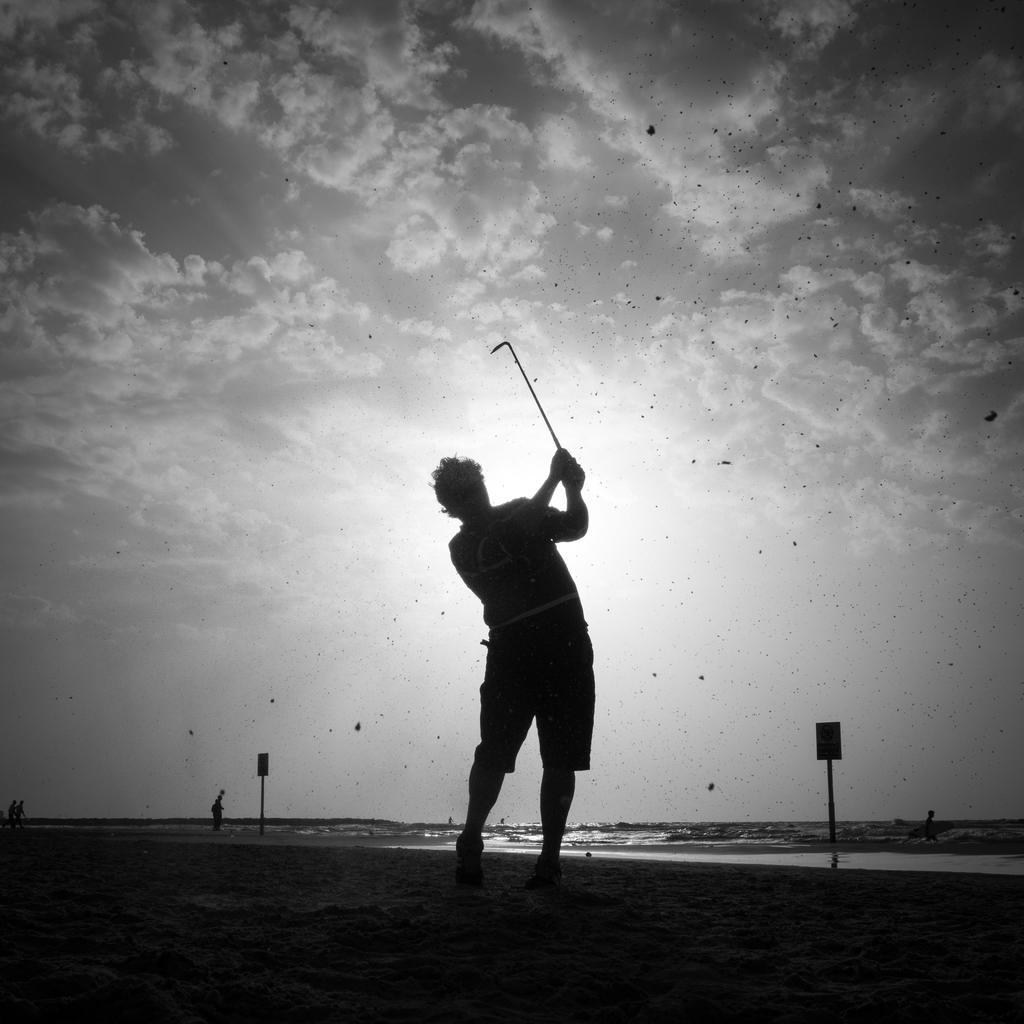Please provide a concise description of this image. This image is a black and white image. This image is taken outdoors. At the top of the image there is a sky with clouds. At the bottom of the image there is a ground. In the middle of the image a man is standing on the ground and he is holding a hockey stick in his hand and there are two sign boards. In the background there is a sea with water. 